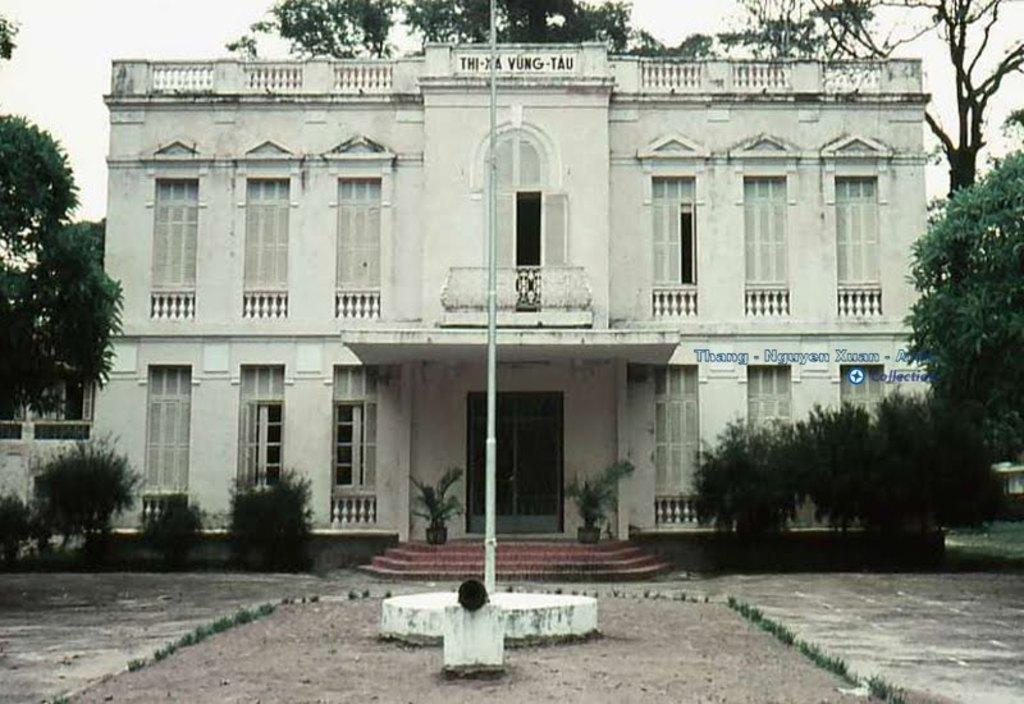What type of structure is visible in the image? There is a building in the image. What features can be seen on the building? The building has windows and doors. What is located in front of the building? There are plants and steps in front of the building. What else can be seen in the image? There is a pole in the image. What type of vegetation is present near the building? There are trees on the sides of the building. What shape is the plastic in the image? There is no plastic present in the image. What time of day is depicted in the image? The time of day cannot be determined from the image. 